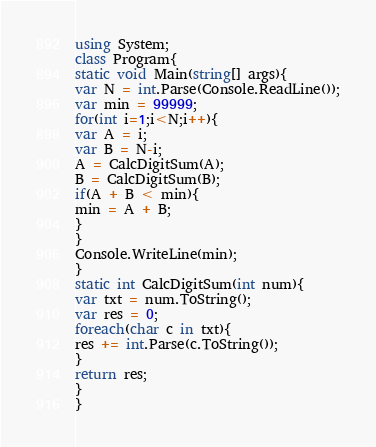Convert code to text. <code><loc_0><loc_0><loc_500><loc_500><_C#_>using System;
class Program{
static void Main(string[] args){
var N = int.Parse(Console.ReadLine());
var min = 99999;
for(int i=1;i<N;i++){
var A = i;
var B = N-i;
A = CalcDigitSum(A);
B = CalcDigitSum(B);
if(A + B < min){
min = A + B;
}
}
Console.WriteLine(min);
}
static int CalcDigitSum(int num){
var txt = num.ToString();
var res = 0;
foreach(char c in txt){
res += int.Parse(c.ToString());
}
return res;
}
}</code> 